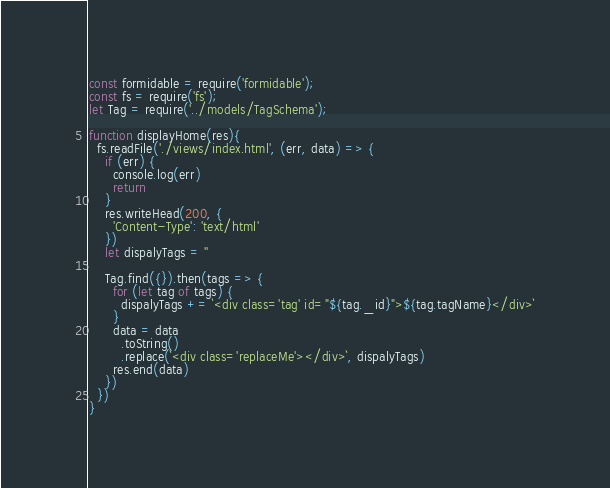Convert code to text. <code><loc_0><loc_0><loc_500><loc_500><_JavaScript_>const formidable = require('formidable');
const fs = require('fs');
let Tag = require('../models/TagSchema');

function displayHome(res){
  fs.readFile('./views/index.html', (err, data) => {
    if (err) {
      console.log(err)
      return
    }
    res.writeHead(200, {
      'Content-Type': 'text/html'
    })
    let dispalyTags = ''

    Tag.find({}).then(tags => {
      for (let tag of tags) {
        dispalyTags += `<div class='tag' id="${tag._id}">${tag.tagName}</div>`
      }
      data = data
        .toString()
        .replace(`<div class='replaceMe'></div>`, dispalyTags)
      res.end(data)
    })
  })
}</code> 